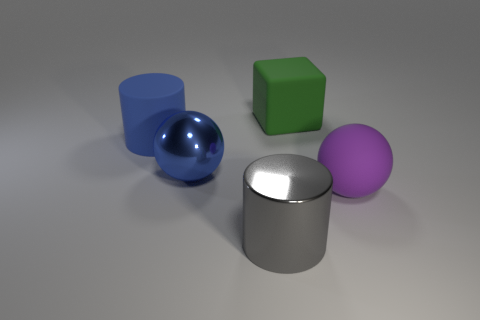Add 1 blue cylinders. How many objects exist? 6 Subtract all spheres. How many objects are left? 3 Add 2 cylinders. How many cylinders exist? 4 Subtract 0 red spheres. How many objects are left? 5 Subtract all red rubber spheres. Subtract all green matte objects. How many objects are left? 4 Add 4 big cylinders. How many big cylinders are left? 6 